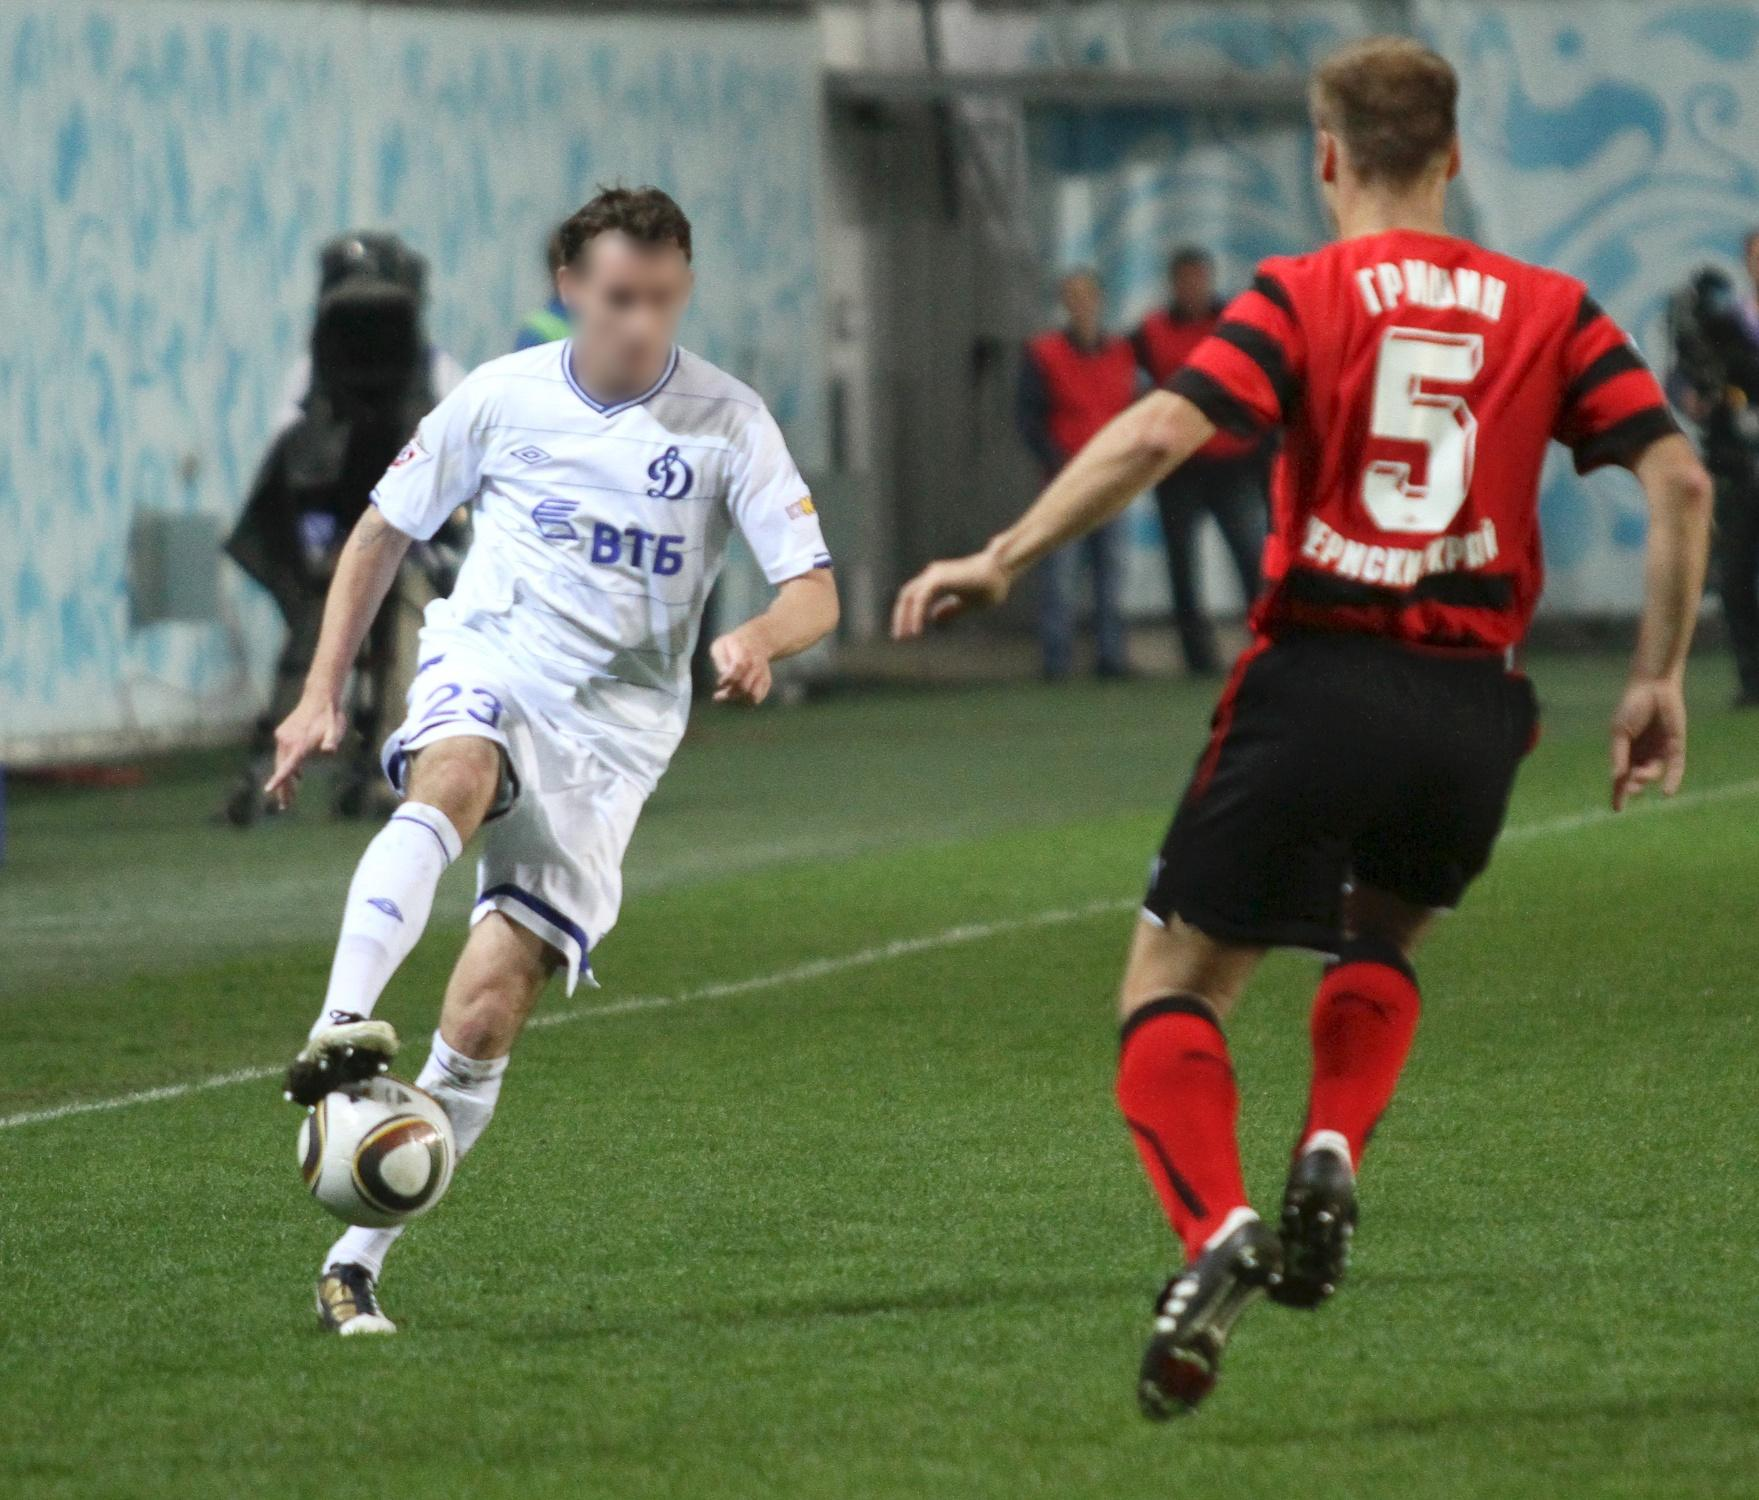Describe the emotions of the players and the atmosphere in the stadium. The players in the image exude sheer determination and focus. The player in the white jersey appears fiercely concentrated on securing the ball, his body language reflecting his commitment to gaining control. The player in the red and black jersey mirrors this intensity, his posture and forward motion suggesting a deep resolve to challenge his opponent. The stadium atmosphere is electric, with the crowd's amorphous presence blending into a sea of spectators visibly engaged in the match. Though their faces are blurred, their collective anticipation and excitement can be felt. The vibrant colors and energetic ambiance amplify the pulsating action on the field, enveloping everyone present in the spirit of the game. What's the likely outcome of their current action? Given the positioning of the players, the likely outcome is that the player in the white jersey will gain control of the ball. He is slightly ahead and seems more poised to make a decisive move, potentially dribbling past his opponent or making a strategic pass to a teammate. The player in the red and black jersey will probably attempt a defensive maneuver, either to intercept the ball or to pressure the player in white into making a quick decision. 